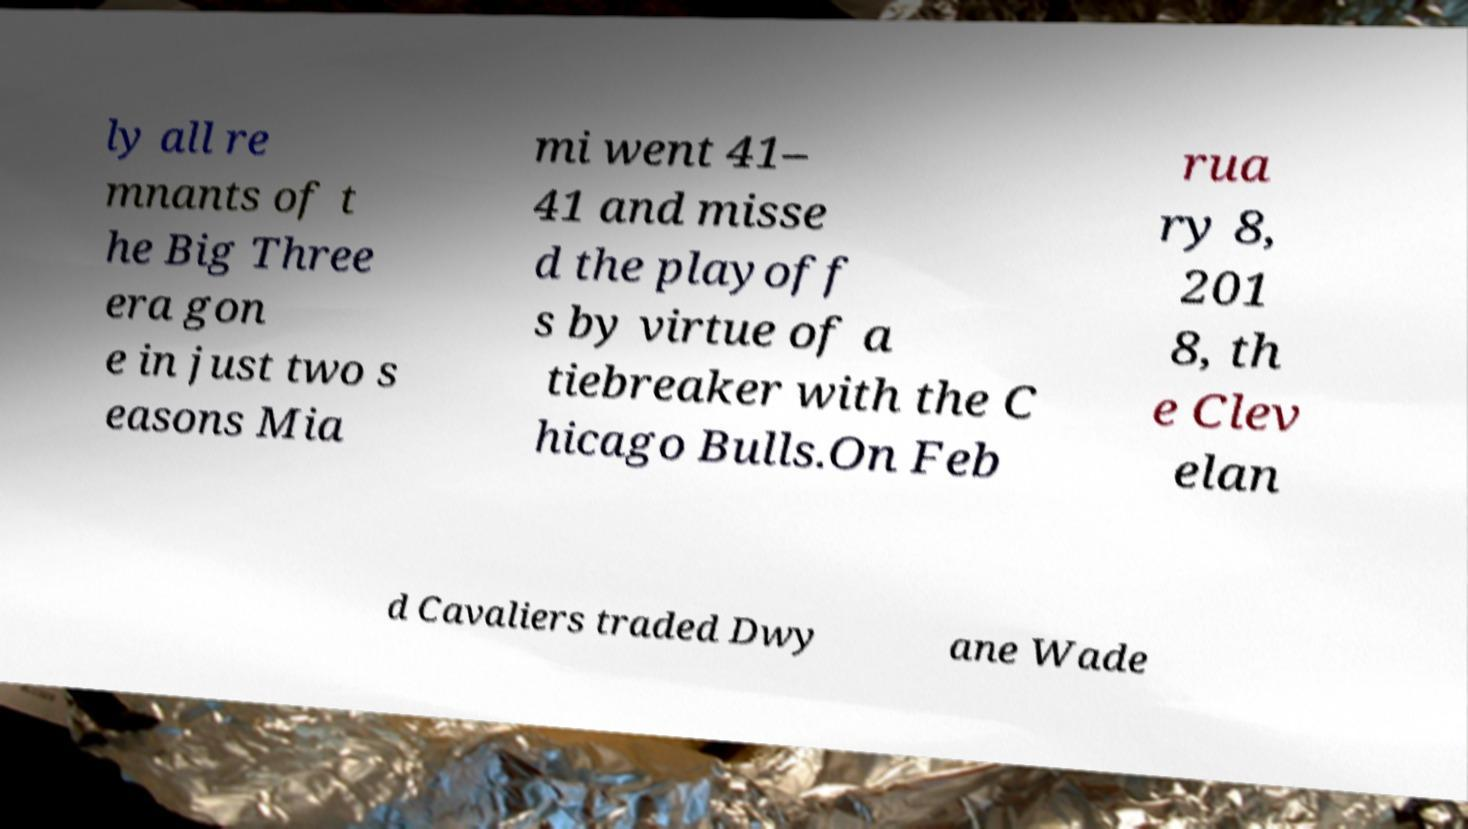What messages or text are displayed in this image? I need them in a readable, typed format. ly all re mnants of t he Big Three era gon e in just two s easons Mia mi went 41– 41 and misse d the playoff s by virtue of a tiebreaker with the C hicago Bulls.On Feb rua ry 8, 201 8, th e Clev elan d Cavaliers traded Dwy ane Wade 